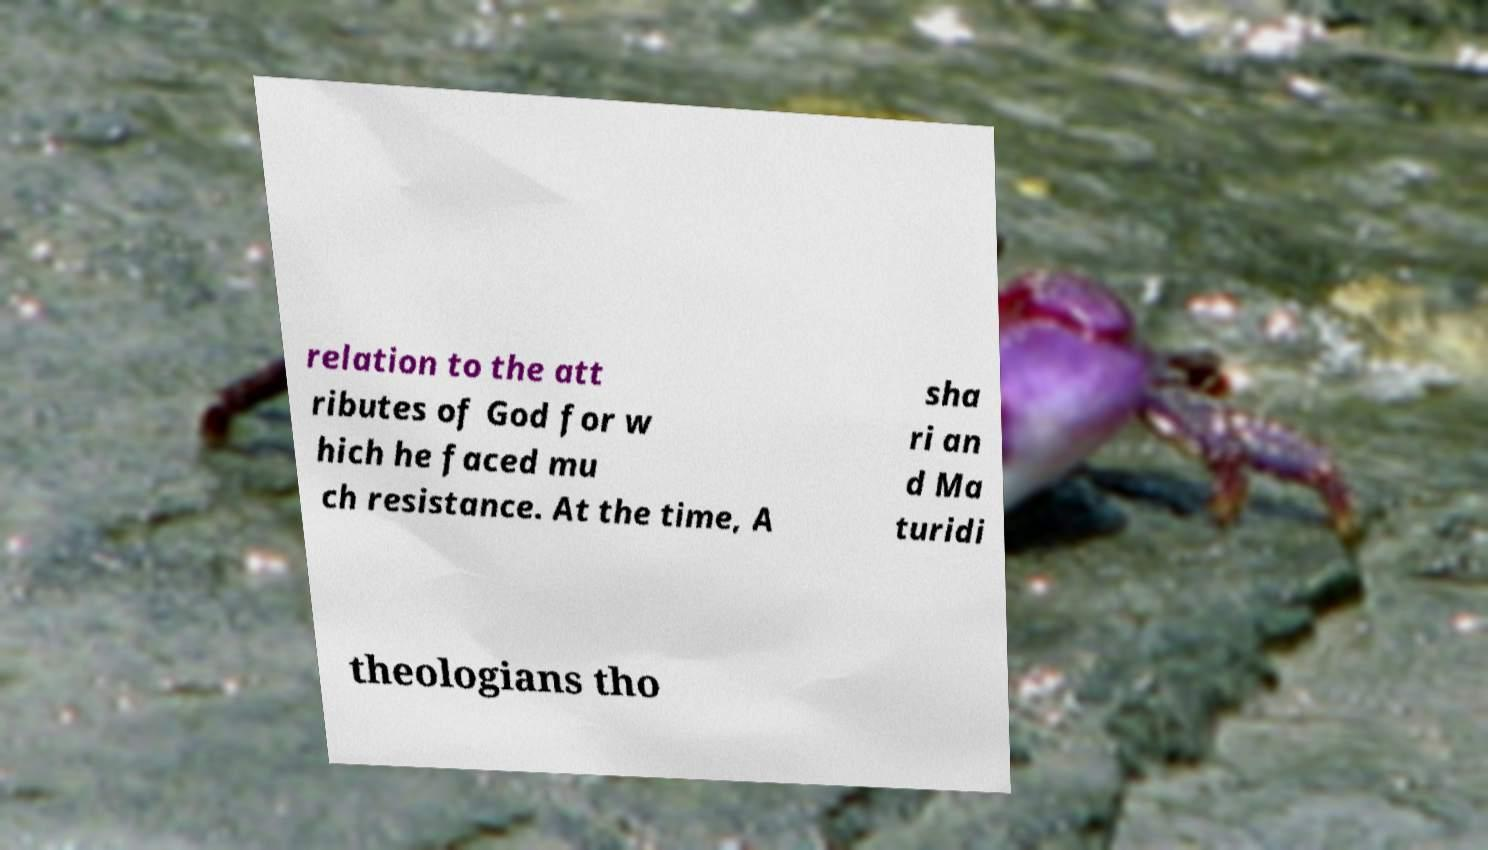Please identify and transcribe the text found in this image. relation to the att ributes of God for w hich he faced mu ch resistance. At the time, A sha ri an d Ma turidi theologians tho 